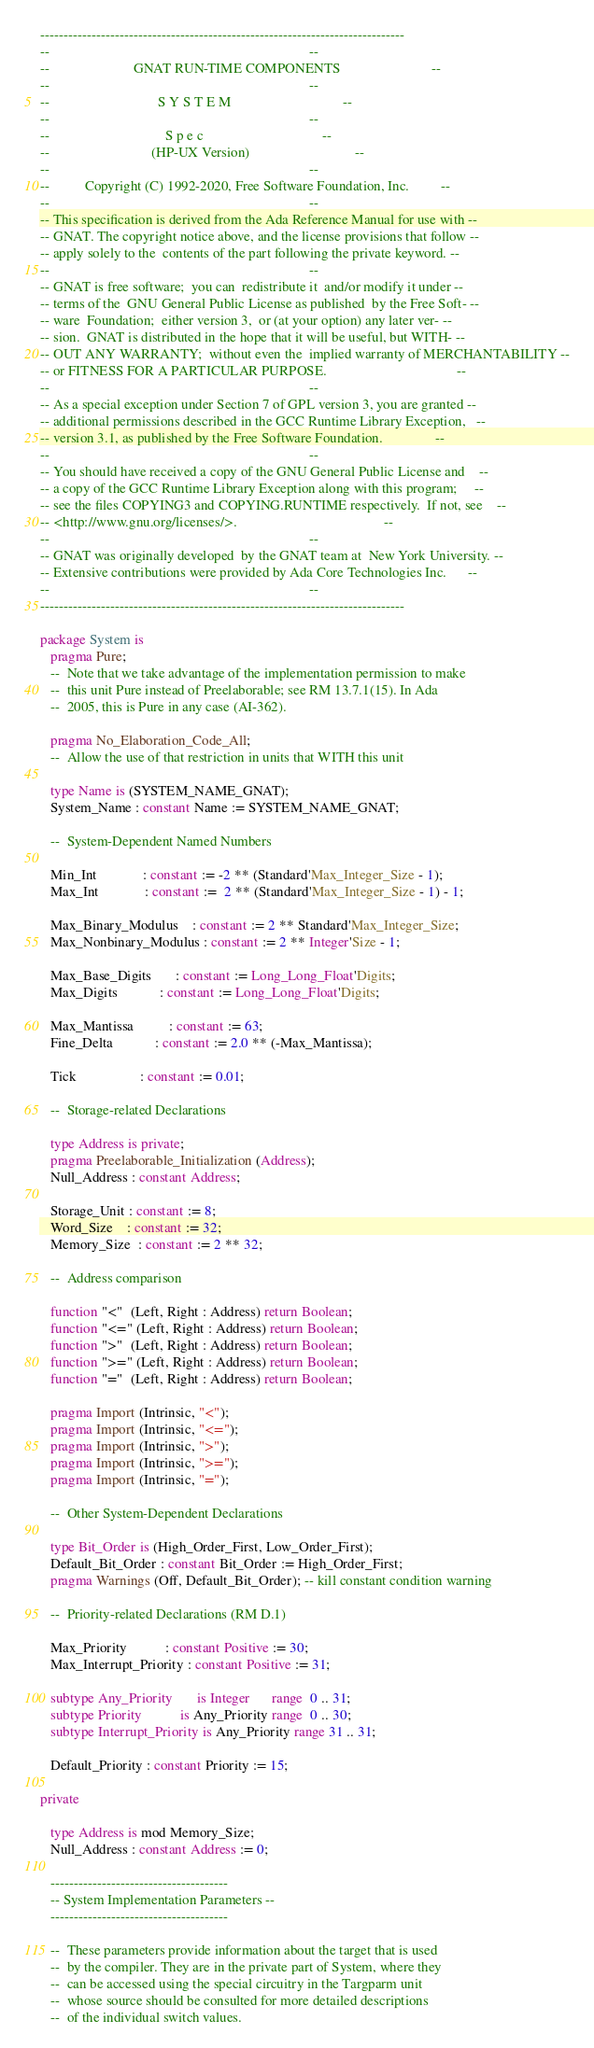<code> <loc_0><loc_0><loc_500><loc_500><_Ada_>------------------------------------------------------------------------------
--                                                                          --
--                        GNAT RUN-TIME COMPONENTS                          --
--                                                                          --
--                               S Y S T E M                                --
--                                                                          --
--                                 S p e c                                  --
--                             (HP-UX Version)                              --
--                                                                          --
--          Copyright (C) 1992-2020, Free Software Foundation, Inc.         --
--                                                                          --
-- This specification is derived from the Ada Reference Manual for use with --
-- GNAT. The copyright notice above, and the license provisions that follow --
-- apply solely to the  contents of the part following the private keyword. --
--                                                                          --
-- GNAT is free software;  you can  redistribute it  and/or modify it under --
-- terms of the  GNU General Public License as published  by the Free Soft- --
-- ware  Foundation;  either version 3,  or (at your option) any later ver- --
-- sion.  GNAT is distributed in the hope that it will be useful, but WITH- --
-- OUT ANY WARRANTY;  without even the  implied warranty of MERCHANTABILITY --
-- or FITNESS FOR A PARTICULAR PURPOSE.                                     --
--                                                                          --
-- As a special exception under Section 7 of GPL version 3, you are granted --
-- additional permissions described in the GCC Runtime Library Exception,   --
-- version 3.1, as published by the Free Software Foundation.               --
--                                                                          --
-- You should have received a copy of the GNU General Public License and    --
-- a copy of the GCC Runtime Library Exception along with this program;     --
-- see the files COPYING3 and COPYING.RUNTIME respectively.  If not, see    --
-- <http://www.gnu.org/licenses/>.                                          --
--                                                                          --
-- GNAT was originally developed  by the GNAT team at  New York University. --
-- Extensive contributions were provided by Ada Core Technologies Inc.      --
--                                                                          --
------------------------------------------------------------------------------

package System is
   pragma Pure;
   --  Note that we take advantage of the implementation permission to make
   --  this unit Pure instead of Preelaborable; see RM 13.7.1(15). In Ada
   --  2005, this is Pure in any case (AI-362).

   pragma No_Elaboration_Code_All;
   --  Allow the use of that restriction in units that WITH this unit

   type Name is (SYSTEM_NAME_GNAT);
   System_Name : constant Name := SYSTEM_NAME_GNAT;

   --  System-Dependent Named Numbers

   Min_Int             : constant := -2 ** (Standard'Max_Integer_Size - 1);
   Max_Int             : constant :=  2 ** (Standard'Max_Integer_Size - 1) - 1;

   Max_Binary_Modulus    : constant := 2 ** Standard'Max_Integer_Size;
   Max_Nonbinary_Modulus : constant := 2 ** Integer'Size - 1;

   Max_Base_Digits       : constant := Long_Long_Float'Digits;
   Max_Digits            : constant := Long_Long_Float'Digits;

   Max_Mantissa          : constant := 63;
   Fine_Delta            : constant := 2.0 ** (-Max_Mantissa);

   Tick                  : constant := 0.01;

   --  Storage-related Declarations

   type Address is private;
   pragma Preelaborable_Initialization (Address);
   Null_Address : constant Address;

   Storage_Unit : constant := 8;
   Word_Size    : constant := 32;
   Memory_Size  : constant := 2 ** 32;

   --  Address comparison

   function "<"  (Left, Right : Address) return Boolean;
   function "<=" (Left, Right : Address) return Boolean;
   function ">"  (Left, Right : Address) return Boolean;
   function ">=" (Left, Right : Address) return Boolean;
   function "="  (Left, Right : Address) return Boolean;

   pragma Import (Intrinsic, "<");
   pragma Import (Intrinsic, "<=");
   pragma Import (Intrinsic, ">");
   pragma Import (Intrinsic, ">=");
   pragma Import (Intrinsic, "=");

   --  Other System-Dependent Declarations

   type Bit_Order is (High_Order_First, Low_Order_First);
   Default_Bit_Order : constant Bit_Order := High_Order_First;
   pragma Warnings (Off, Default_Bit_Order); -- kill constant condition warning

   --  Priority-related Declarations (RM D.1)

   Max_Priority           : constant Positive := 30;
   Max_Interrupt_Priority : constant Positive := 31;

   subtype Any_Priority       is Integer      range  0 .. 31;
   subtype Priority           is Any_Priority range  0 .. 30;
   subtype Interrupt_Priority is Any_Priority range 31 .. 31;

   Default_Priority : constant Priority := 15;

private

   type Address is mod Memory_Size;
   Null_Address : constant Address := 0;

   --------------------------------------
   -- System Implementation Parameters --
   --------------------------------------

   --  These parameters provide information about the target that is used
   --  by the compiler. They are in the private part of System, where they
   --  can be accessed using the special circuitry in the Targparm unit
   --  whose source should be consulted for more detailed descriptions
   --  of the individual switch values.
</code> 